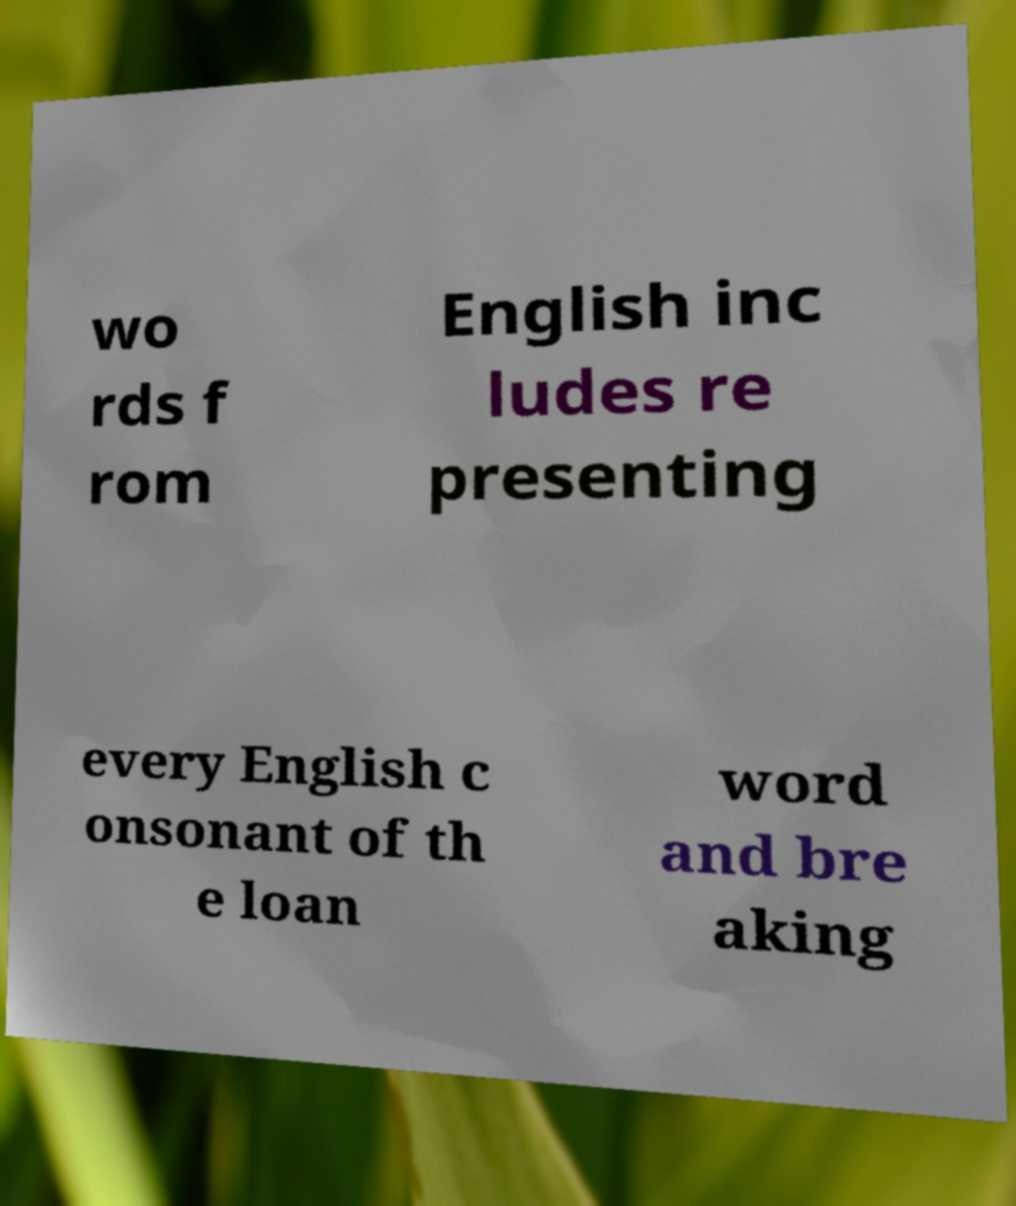I need the written content from this picture converted into text. Can you do that? wo rds f rom English inc ludes re presenting every English c onsonant of th e loan word and bre aking 